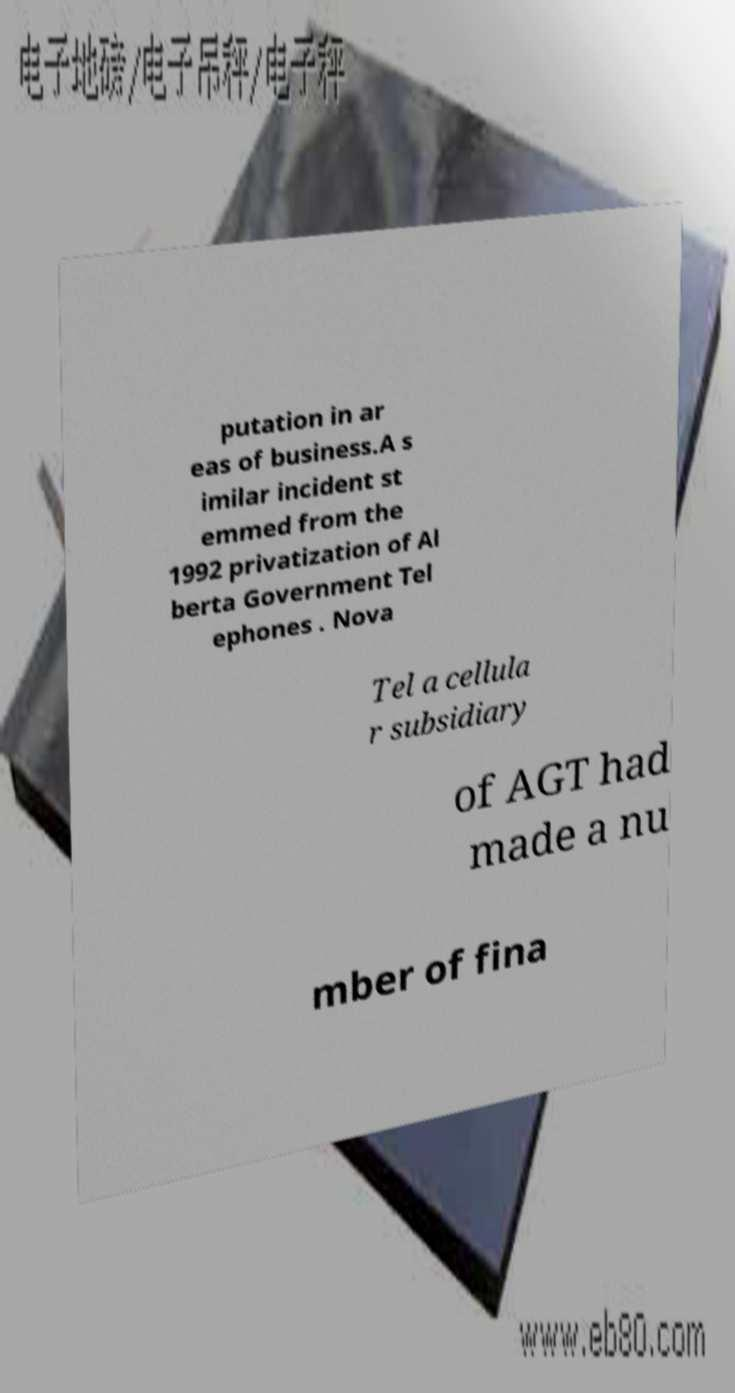Can you accurately transcribe the text from the provided image for me? putation in ar eas of business.A s imilar incident st emmed from the 1992 privatization of Al berta Government Tel ephones . Nova Tel a cellula r subsidiary of AGT had made a nu mber of fina 